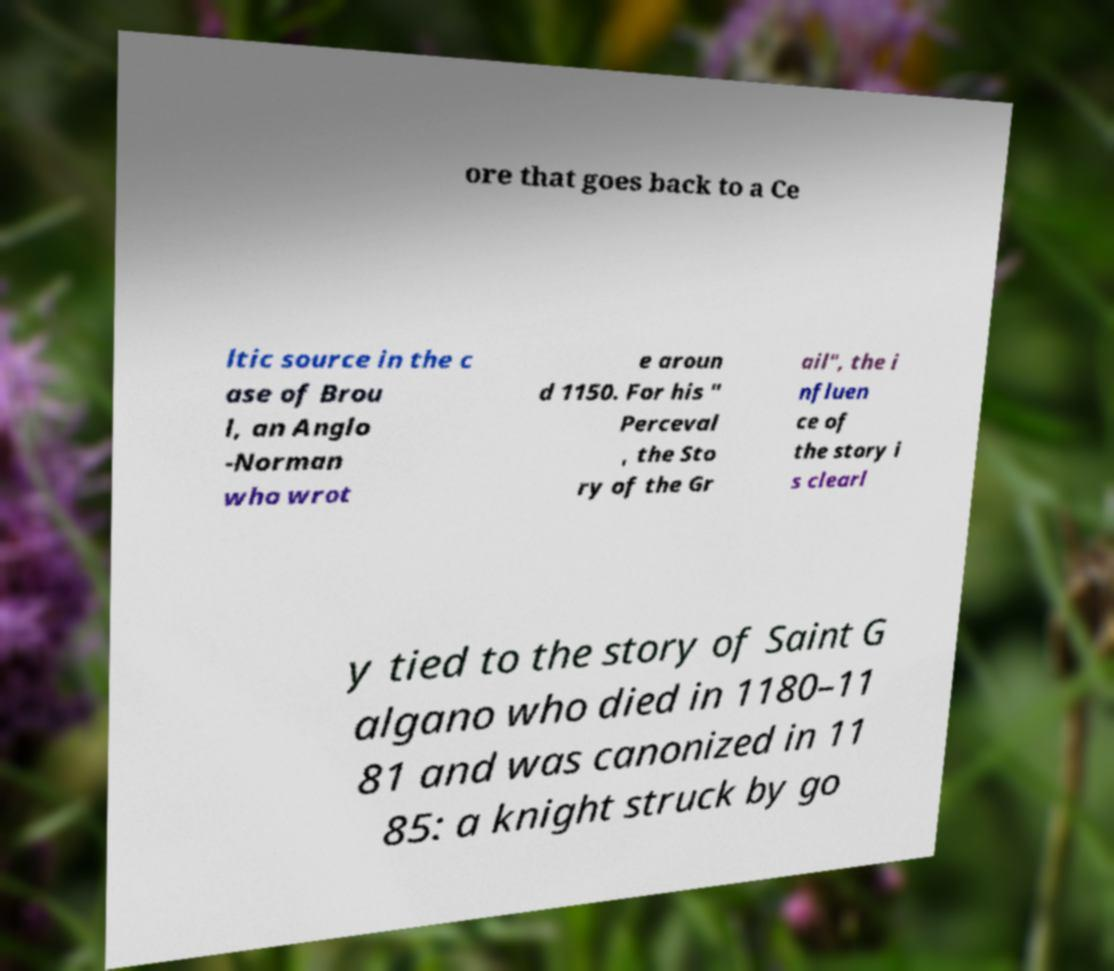What messages or text are displayed in this image? I need them in a readable, typed format. ore that goes back to a Ce ltic source in the c ase of Brou l, an Anglo -Norman who wrot e aroun d 1150. For his " Perceval , the Sto ry of the Gr ail", the i nfluen ce of the story i s clearl y tied to the story of Saint G algano who died in 1180–11 81 and was canonized in 11 85: a knight struck by go 